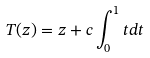<formula> <loc_0><loc_0><loc_500><loc_500>T ( z ) = z + c \int _ { 0 } ^ { 1 } t d t</formula> 